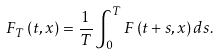Convert formula to latex. <formula><loc_0><loc_0><loc_500><loc_500>F _ { T } \left ( t , x \right ) = \frac { 1 } { T } \int _ { 0 } ^ { T } F \left ( t + s , x \right ) d s .</formula> 